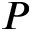Convert formula to latex. <formula><loc_0><loc_0><loc_500><loc_500>P</formula> 